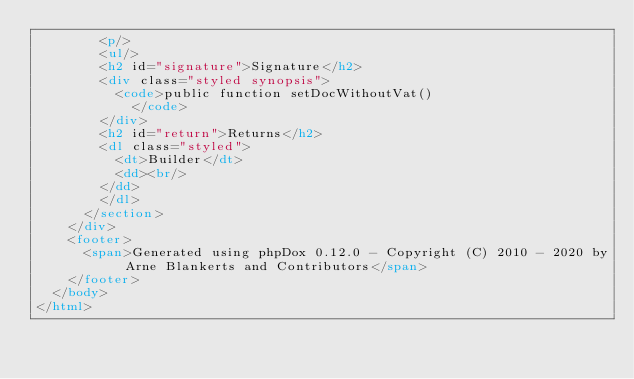<code> <loc_0><loc_0><loc_500><loc_500><_HTML_>        <p/>
        <ul/>
        <h2 id="signature">Signature</h2>
        <div class="styled synopsis">
          <code>public function setDocWithoutVat()
            </code>
        </div>
        <h2 id="return">Returns</h2>
        <dl class="styled">
          <dt>Builder</dt>
          <dd><br/>
        </dd>
        </dl>
      </section>
    </div>
    <footer>
      <span>Generated using phpDox 0.12.0 - Copyright (C) 2010 - 2020 by Arne Blankerts and Contributors</span>
    </footer>
  </body>
</html>
</code> 